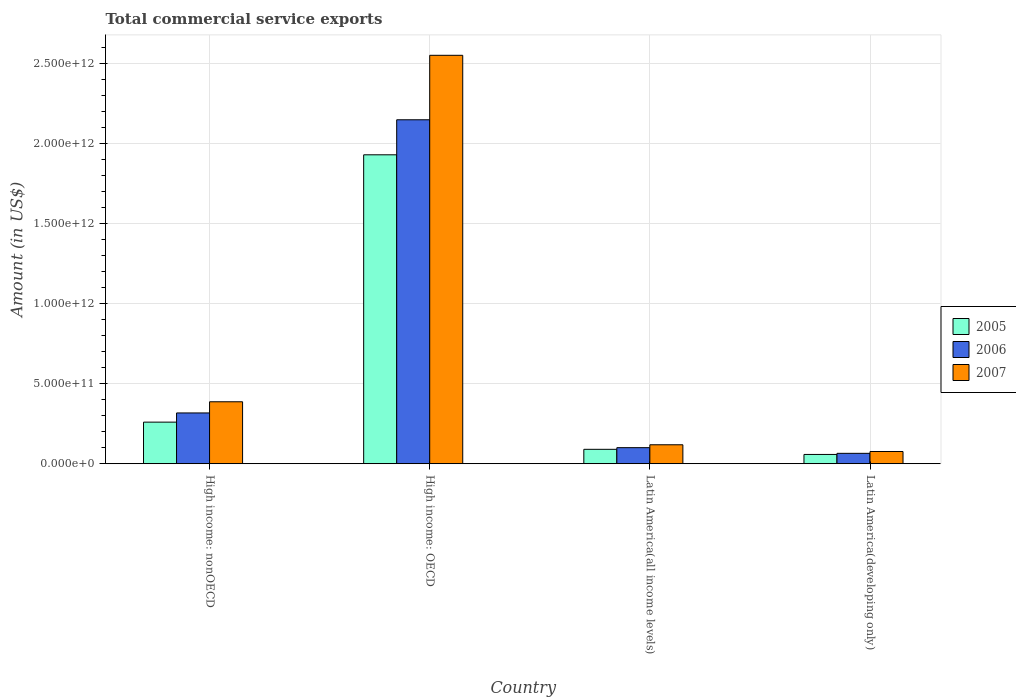Are the number of bars per tick equal to the number of legend labels?
Offer a terse response. Yes. Are the number of bars on each tick of the X-axis equal?
Give a very brief answer. Yes. How many bars are there on the 3rd tick from the left?
Offer a terse response. 3. What is the label of the 4th group of bars from the left?
Provide a succinct answer. Latin America(developing only). What is the total commercial service exports in 2006 in Latin America(all income levels)?
Provide a short and direct response. 1.00e+11. Across all countries, what is the maximum total commercial service exports in 2007?
Your answer should be very brief. 2.55e+12. Across all countries, what is the minimum total commercial service exports in 2006?
Give a very brief answer. 6.49e+1. In which country was the total commercial service exports in 2005 maximum?
Your answer should be compact. High income: OECD. In which country was the total commercial service exports in 2006 minimum?
Your answer should be very brief. Latin America(developing only). What is the total total commercial service exports in 2007 in the graph?
Your answer should be very brief. 3.13e+12. What is the difference between the total commercial service exports in 2005 in High income: OECD and that in Latin America(all income levels)?
Your answer should be compact. 1.84e+12. What is the difference between the total commercial service exports in 2005 in Latin America(all income levels) and the total commercial service exports in 2006 in High income: nonOECD?
Your answer should be very brief. -2.27e+11. What is the average total commercial service exports in 2005 per country?
Provide a succinct answer. 5.84e+11. What is the difference between the total commercial service exports of/in 2006 and total commercial service exports of/in 2005 in High income: OECD?
Provide a succinct answer. 2.19e+11. In how many countries, is the total commercial service exports in 2007 greater than 900000000000 US$?
Keep it short and to the point. 1. What is the ratio of the total commercial service exports in 2006 in Latin America(all income levels) to that in Latin America(developing only)?
Offer a very short reply. 1.55. Is the difference between the total commercial service exports in 2006 in High income: nonOECD and Latin America(all income levels) greater than the difference between the total commercial service exports in 2005 in High income: nonOECD and Latin America(all income levels)?
Provide a succinct answer. Yes. What is the difference between the highest and the second highest total commercial service exports in 2005?
Make the answer very short. -1.70e+11. What is the difference between the highest and the lowest total commercial service exports in 2005?
Offer a very short reply. 1.87e+12. In how many countries, is the total commercial service exports in 2007 greater than the average total commercial service exports in 2007 taken over all countries?
Offer a very short reply. 1. What does the 3rd bar from the left in Latin America(developing only) represents?
Your answer should be very brief. 2007. What does the 1st bar from the right in Latin America(all income levels) represents?
Provide a succinct answer. 2007. Are all the bars in the graph horizontal?
Provide a short and direct response. No. What is the difference between two consecutive major ticks on the Y-axis?
Your response must be concise. 5.00e+11. Are the values on the major ticks of Y-axis written in scientific E-notation?
Keep it short and to the point. Yes. Where does the legend appear in the graph?
Give a very brief answer. Center right. How are the legend labels stacked?
Provide a succinct answer. Vertical. What is the title of the graph?
Your response must be concise. Total commercial service exports. What is the label or title of the Y-axis?
Keep it short and to the point. Amount (in US$). What is the Amount (in US$) of 2005 in High income: nonOECD?
Provide a succinct answer. 2.60e+11. What is the Amount (in US$) of 2006 in High income: nonOECD?
Make the answer very short. 3.17e+11. What is the Amount (in US$) of 2007 in High income: nonOECD?
Give a very brief answer. 3.87e+11. What is the Amount (in US$) in 2005 in High income: OECD?
Offer a very short reply. 1.93e+12. What is the Amount (in US$) of 2006 in High income: OECD?
Keep it short and to the point. 2.15e+12. What is the Amount (in US$) in 2007 in High income: OECD?
Ensure brevity in your answer.  2.55e+12. What is the Amount (in US$) of 2005 in Latin America(all income levels)?
Provide a short and direct response. 9.00e+1. What is the Amount (in US$) of 2006 in Latin America(all income levels)?
Your answer should be compact. 1.00e+11. What is the Amount (in US$) of 2007 in Latin America(all income levels)?
Provide a succinct answer. 1.18e+11. What is the Amount (in US$) in 2005 in Latin America(developing only)?
Your answer should be compact. 5.80e+1. What is the Amount (in US$) in 2006 in Latin America(developing only)?
Offer a terse response. 6.49e+1. What is the Amount (in US$) in 2007 in Latin America(developing only)?
Provide a short and direct response. 7.63e+1. Across all countries, what is the maximum Amount (in US$) of 2005?
Provide a short and direct response. 1.93e+12. Across all countries, what is the maximum Amount (in US$) of 2006?
Make the answer very short. 2.15e+12. Across all countries, what is the maximum Amount (in US$) of 2007?
Make the answer very short. 2.55e+12. Across all countries, what is the minimum Amount (in US$) in 2005?
Give a very brief answer. 5.80e+1. Across all countries, what is the minimum Amount (in US$) of 2006?
Your answer should be very brief. 6.49e+1. Across all countries, what is the minimum Amount (in US$) in 2007?
Offer a very short reply. 7.63e+1. What is the total Amount (in US$) in 2005 in the graph?
Ensure brevity in your answer.  2.34e+12. What is the total Amount (in US$) of 2006 in the graph?
Give a very brief answer. 2.63e+12. What is the total Amount (in US$) in 2007 in the graph?
Offer a terse response. 3.13e+12. What is the difference between the Amount (in US$) in 2005 in High income: nonOECD and that in High income: OECD?
Offer a very short reply. -1.67e+12. What is the difference between the Amount (in US$) in 2006 in High income: nonOECD and that in High income: OECD?
Provide a succinct answer. -1.83e+12. What is the difference between the Amount (in US$) in 2007 in High income: nonOECD and that in High income: OECD?
Your answer should be very brief. -2.16e+12. What is the difference between the Amount (in US$) of 2005 in High income: nonOECD and that in Latin America(all income levels)?
Provide a short and direct response. 1.70e+11. What is the difference between the Amount (in US$) of 2006 in High income: nonOECD and that in Latin America(all income levels)?
Ensure brevity in your answer.  2.17e+11. What is the difference between the Amount (in US$) of 2007 in High income: nonOECD and that in Latin America(all income levels)?
Give a very brief answer. 2.68e+11. What is the difference between the Amount (in US$) in 2005 in High income: nonOECD and that in Latin America(developing only)?
Ensure brevity in your answer.  2.02e+11. What is the difference between the Amount (in US$) in 2006 in High income: nonOECD and that in Latin America(developing only)?
Make the answer very short. 2.52e+11. What is the difference between the Amount (in US$) in 2007 in High income: nonOECD and that in Latin America(developing only)?
Offer a terse response. 3.10e+11. What is the difference between the Amount (in US$) in 2005 in High income: OECD and that in Latin America(all income levels)?
Ensure brevity in your answer.  1.84e+12. What is the difference between the Amount (in US$) in 2006 in High income: OECD and that in Latin America(all income levels)?
Make the answer very short. 2.05e+12. What is the difference between the Amount (in US$) of 2007 in High income: OECD and that in Latin America(all income levels)?
Offer a very short reply. 2.43e+12. What is the difference between the Amount (in US$) in 2005 in High income: OECD and that in Latin America(developing only)?
Offer a very short reply. 1.87e+12. What is the difference between the Amount (in US$) of 2006 in High income: OECD and that in Latin America(developing only)?
Your answer should be compact. 2.08e+12. What is the difference between the Amount (in US$) of 2007 in High income: OECD and that in Latin America(developing only)?
Make the answer very short. 2.47e+12. What is the difference between the Amount (in US$) of 2005 in Latin America(all income levels) and that in Latin America(developing only)?
Provide a succinct answer. 3.20e+1. What is the difference between the Amount (in US$) in 2006 in Latin America(all income levels) and that in Latin America(developing only)?
Your answer should be very brief. 3.54e+1. What is the difference between the Amount (in US$) in 2007 in Latin America(all income levels) and that in Latin America(developing only)?
Offer a very short reply. 4.20e+1. What is the difference between the Amount (in US$) of 2005 in High income: nonOECD and the Amount (in US$) of 2006 in High income: OECD?
Give a very brief answer. -1.89e+12. What is the difference between the Amount (in US$) in 2005 in High income: nonOECD and the Amount (in US$) in 2007 in High income: OECD?
Your answer should be compact. -2.29e+12. What is the difference between the Amount (in US$) of 2006 in High income: nonOECD and the Amount (in US$) of 2007 in High income: OECD?
Provide a succinct answer. -2.23e+12. What is the difference between the Amount (in US$) in 2005 in High income: nonOECD and the Amount (in US$) in 2006 in Latin America(all income levels)?
Make the answer very short. 1.59e+11. What is the difference between the Amount (in US$) in 2005 in High income: nonOECD and the Amount (in US$) in 2007 in Latin America(all income levels)?
Your answer should be compact. 1.41e+11. What is the difference between the Amount (in US$) of 2006 in High income: nonOECD and the Amount (in US$) of 2007 in Latin America(all income levels)?
Provide a succinct answer. 1.99e+11. What is the difference between the Amount (in US$) of 2005 in High income: nonOECD and the Amount (in US$) of 2006 in Latin America(developing only)?
Provide a short and direct response. 1.95e+11. What is the difference between the Amount (in US$) in 2005 in High income: nonOECD and the Amount (in US$) in 2007 in Latin America(developing only)?
Your answer should be very brief. 1.83e+11. What is the difference between the Amount (in US$) in 2006 in High income: nonOECD and the Amount (in US$) in 2007 in Latin America(developing only)?
Offer a very short reply. 2.41e+11. What is the difference between the Amount (in US$) in 2005 in High income: OECD and the Amount (in US$) in 2006 in Latin America(all income levels)?
Your answer should be very brief. 1.83e+12. What is the difference between the Amount (in US$) in 2005 in High income: OECD and the Amount (in US$) in 2007 in Latin America(all income levels)?
Offer a very short reply. 1.81e+12. What is the difference between the Amount (in US$) in 2006 in High income: OECD and the Amount (in US$) in 2007 in Latin America(all income levels)?
Provide a succinct answer. 2.03e+12. What is the difference between the Amount (in US$) of 2005 in High income: OECD and the Amount (in US$) of 2006 in Latin America(developing only)?
Keep it short and to the point. 1.86e+12. What is the difference between the Amount (in US$) of 2005 in High income: OECD and the Amount (in US$) of 2007 in Latin America(developing only)?
Provide a short and direct response. 1.85e+12. What is the difference between the Amount (in US$) in 2006 in High income: OECD and the Amount (in US$) in 2007 in Latin America(developing only)?
Offer a terse response. 2.07e+12. What is the difference between the Amount (in US$) in 2005 in Latin America(all income levels) and the Amount (in US$) in 2006 in Latin America(developing only)?
Ensure brevity in your answer.  2.51e+1. What is the difference between the Amount (in US$) in 2005 in Latin America(all income levels) and the Amount (in US$) in 2007 in Latin America(developing only)?
Your answer should be compact. 1.37e+1. What is the difference between the Amount (in US$) in 2006 in Latin America(all income levels) and the Amount (in US$) in 2007 in Latin America(developing only)?
Offer a terse response. 2.40e+1. What is the average Amount (in US$) in 2005 per country?
Your response must be concise. 5.84e+11. What is the average Amount (in US$) of 2006 per country?
Offer a terse response. 6.57e+11. What is the average Amount (in US$) in 2007 per country?
Provide a short and direct response. 7.83e+11. What is the difference between the Amount (in US$) of 2005 and Amount (in US$) of 2006 in High income: nonOECD?
Offer a terse response. -5.73e+1. What is the difference between the Amount (in US$) of 2005 and Amount (in US$) of 2007 in High income: nonOECD?
Your answer should be very brief. -1.27e+11. What is the difference between the Amount (in US$) in 2006 and Amount (in US$) in 2007 in High income: nonOECD?
Offer a terse response. -6.97e+1. What is the difference between the Amount (in US$) of 2005 and Amount (in US$) of 2006 in High income: OECD?
Offer a terse response. -2.19e+11. What is the difference between the Amount (in US$) of 2005 and Amount (in US$) of 2007 in High income: OECD?
Provide a succinct answer. -6.21e+11. What is the difference between the Amount (in US$) of 2006 and Amount (in US$) of 2007 in High income: OECD?
Your answer should be very brief. -4.02e+11. What is the difference between the Amount (in US$) of 2005 and Amount (in US$) of 2006 in Latin America(all income levels)?
Your answer should be very brief. -1.03e+1. What is the difference between the Amount (in US$) in 2005 and Amount (in US$) in 2007 in Latin America(all income levels)?
Ensure brevity in your answer.  -2.83e+1. What is the difference between the Amount (in US$) in 2006 and Amount (in US$) in 2007 in Latin America(all income levels)?
Provide a succinct answer. -1.80e+1. What is the difference between the Amount (in US$) of 2005 and Amount (in US$) of 2006 in Latin America(developing only)?
Offer a very short reply. -6.88e+09. What is the difference between the Amount (in US$) in 2005 and Amount (in US$) in 2007 in Latin America(developing only)?
Ensure brevity in your answer.  -1.83e+1. What is the difference between the Amount (in US$) in 2006 and Amount (in US$) in 2007 in Latin America(developing only)?
Provide a short and direct response. -1.14e+1. What is the ratio of the Amount (in US$) of 2005 in High income: nonOECD to that in High income: OECD?
Make the answer very short. 0.13. What is the ratio of the Amount (in US$) in 2006 in High income: nonOECD to that in High income: OECD?
Make the answer very short. 0.15. What is the ratio of the Amount (in US$) in 2007 in High income: nonOECD to that in High income: OECD?
Make the answer very short. 0.15. What is the ratio of the Amount (in US$) in 2005 in High income: nonOECD to that in Latin America(all income levels)?
Your answer should be very brief. 2.89. What is the ratio of the Amount (in US$) of 2006 in High income: nonOECD to that in Latin America(all income levels)?
Your answer should be compact. 3.16. What is the ratio of the Amount (in US$) of 2007 in High income: nonOECD to that in Latin America(all income levels)?
Keep it short and to the point. 3.27. What is the ratio of the Amount (in US$) of 2005 in High income: nonOECD to that in Latin America(developing only)?
Offer a very short reply. 4.48. What is the ratio of the Amount (in US$) in 2006 in High income: nonOECD to that in Latin America(developing only)?
Provide a succinct answer. 4.89. What is the ratio of the Amount (in US$) in 2007 in High income: nonOECD to that in Latin America(developing only)?
Provide a short and direct response. 5.07. What is the ratio of the Amount (in US$) in 2005 in High income: OECD to that in Latin America(all income levels)?
Your answer should be very brief. 21.42. What is the ratio of the Amount (in US$) in 2006 in High income: OECD to that in Latin America(all income levels)?
Offer a terse response. 21.39. What is the ratio of the Amount (in US$) in 2007 in High income: OECD to that in Latin America(all income levels)?
Your response must be concise. 21.54. What is the ratio of the Amount (in US$) in 2005 in High income: OECD to that in Latin America(developing only)?
Your answer should be very brief. 33.24. What is the ratio of the Amount (in US$) of 2006 in High income: OECD to that in Latin America(developing only)?
Keep it short and to the point. 33.08. What is the ratio of the Amount (in US$) of 2007 in High income: OECD to that in Latin America(developing only)?
Provide a succinct answer. 33.41. What is the ratio of the Amount (in US$) in 2005 in Latin America(all income levels) to that in Latin America(developing only)?
Provide a short and direct response. 1.55. What is the ratio of the Amount (in US$) in 2006 in Latin America(all income levels) to that in Latin America(developing only)?
Keep it short and to the point. 1.55. What is the ratio of the Amount (in US$) in 2007 in Latin America(all income levels) to that in Latin America(developing only)?
Offer a very short reply. 1.55. What is the difference between the highest and the second highest Amount (in US$) of 2005?
Make the answer very short. 1.67e+12. What is the difference between the highest and the second highest Amount (in US$) of 2006?
Your response must be concise. 1.83e+12. What is the difference between the highest and the second highest Amount (in US$) in 2007?
Keep it short and to the point. 2.16e+12. What is the difference between the highest and the lowest Amount (in US$) of 2005?
Provide a succinct answer. 1.87e+12. What is the difference between the highest and the lowest Amount (in US$) in 2006?
Give a very brief answer. 2.08e+12. What is the difference between the highest and the lowest Amount (in US$) in 2007?
Give a very brief answer. 2.47e+12. 